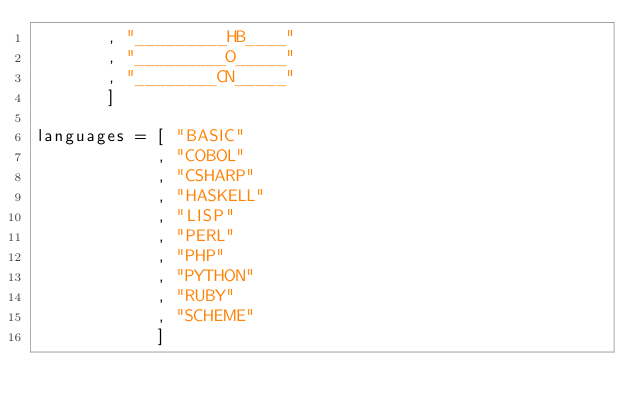<code> <loc_0><loc_0><loc_500><loc_500><_Haskell_>       , "_________HB____"
       , "_________O_____"
       , "________CN_____"
       ]

languages = [ "BASIC"
            , "COBOL"
            , "CSHARP"
            , "HASKELL"
            , "LISP"
            , "PERL"
            , "PHP"
            , "PYTHON"
            , "RUBY"
            , "SCHEME"
            ]
</code> 